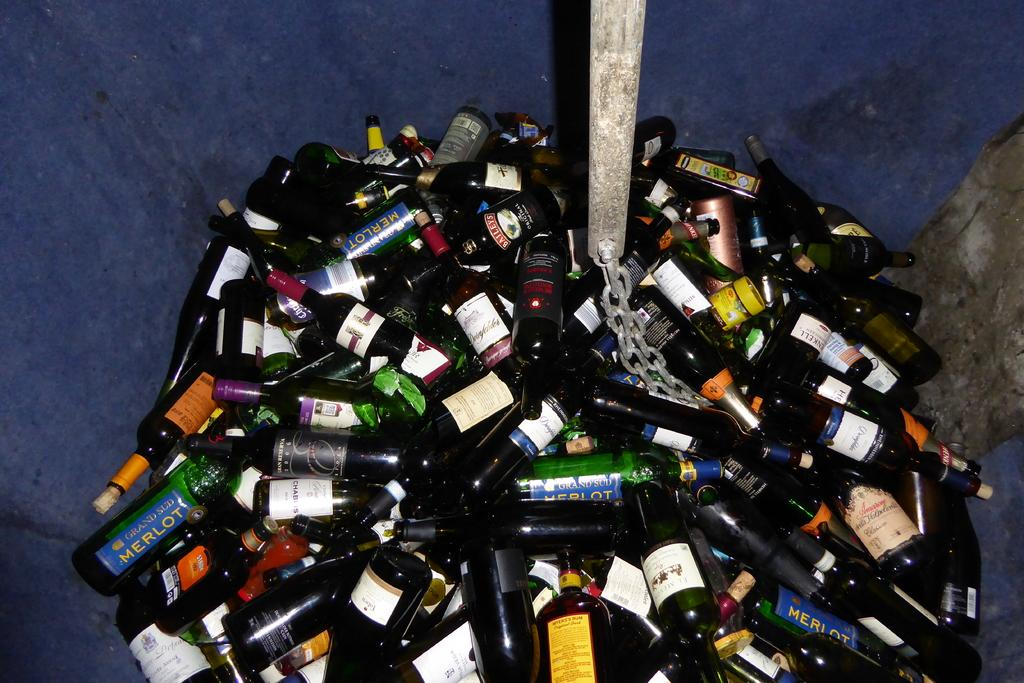<image>
Render a clear and concise summary of the photo. Large bunch of empty wine bottles with a blue Merlot bottle on the lower left. 